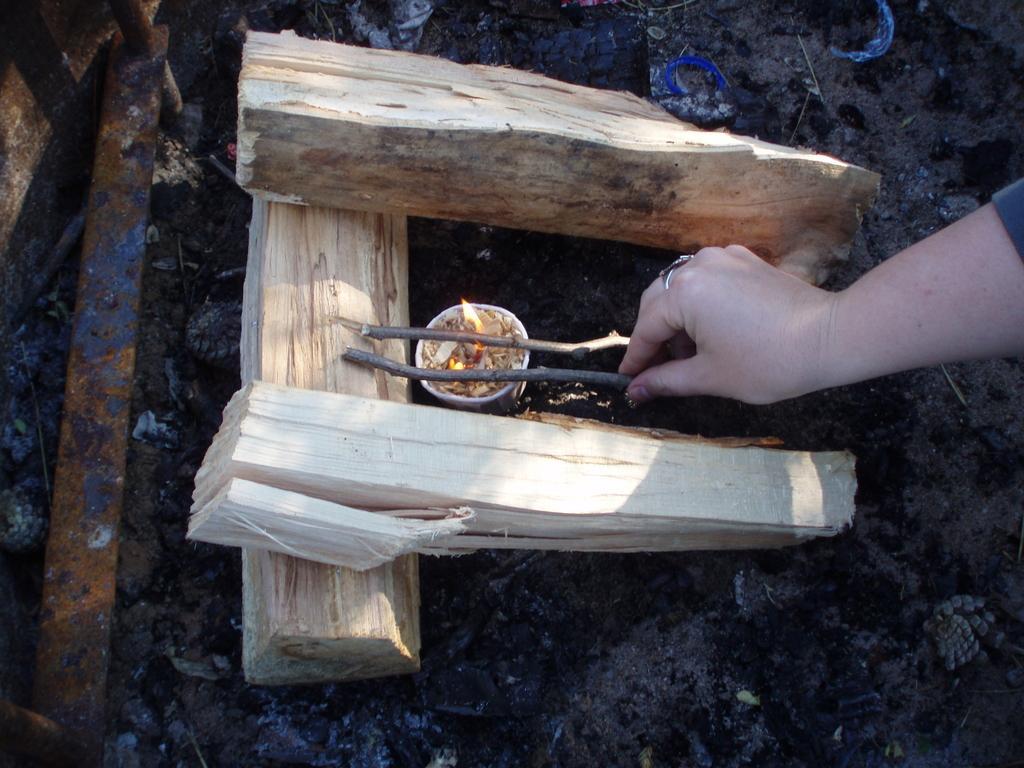Please provide a concise description of this image. In this picture I can see the person's hand who is holding the sticks. In the center I can see the cup and fire. Beside that I can see the woods. On the left I can see some steel scale which is placed on the floor. 